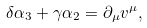Convert formula to latex. <formula><loc_0><loc_0><loc_500><loc_500>\delta \alpha _ { 3 } + \gamma \alpha _ { 2 } = \partial _ { \mu } v ^ { \mu } ,</formula> 